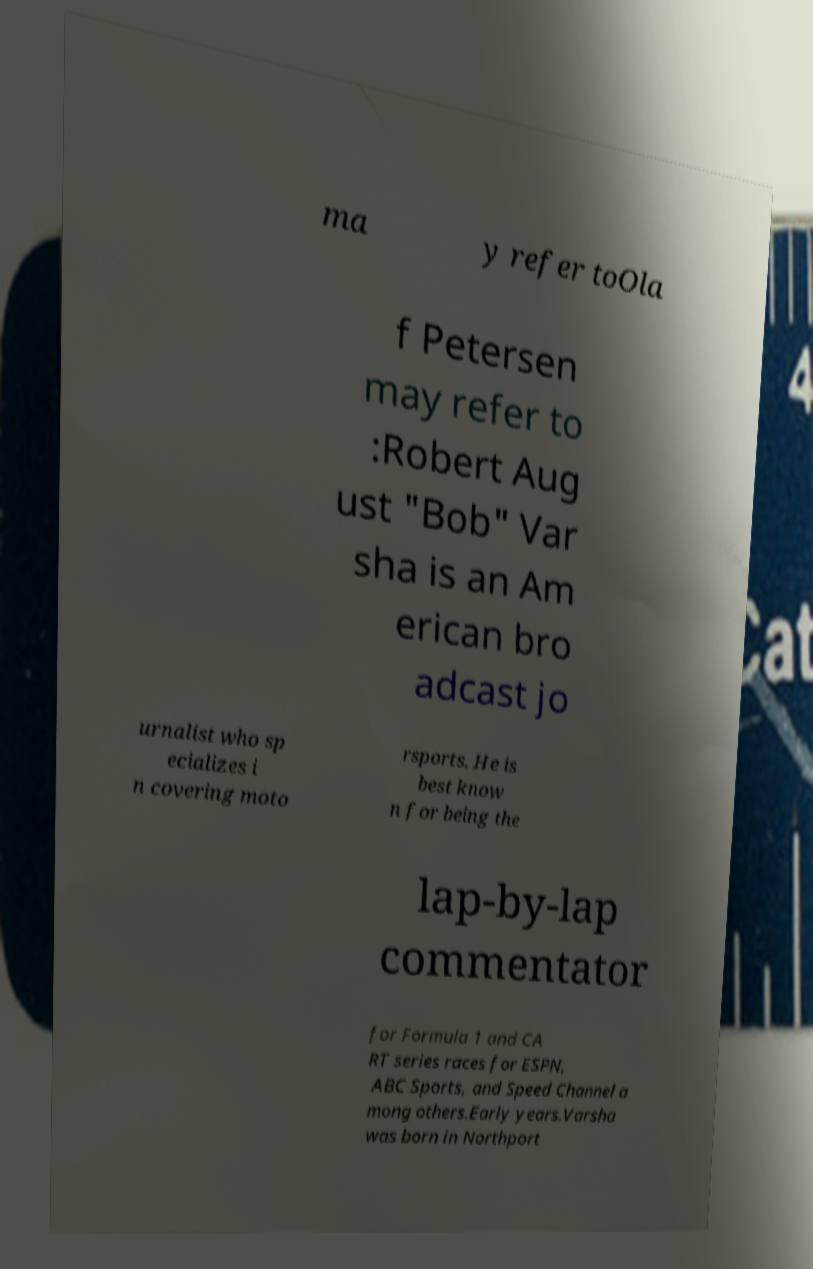Could you extract and type out the text from this image? ma y refer toOla f Petersen may refer to :Robert Aug ust "Bob" Var sha is an Am erican bro adcast jo urnalist who sp ecializes i n covering moto rsports. He is best know n for being the lap-by-lap commentator for Formula 1 and CA RT series races for ESPN, ABC Sports, and Speed Channel a mong others.Early years.Varsha was born in Northport 